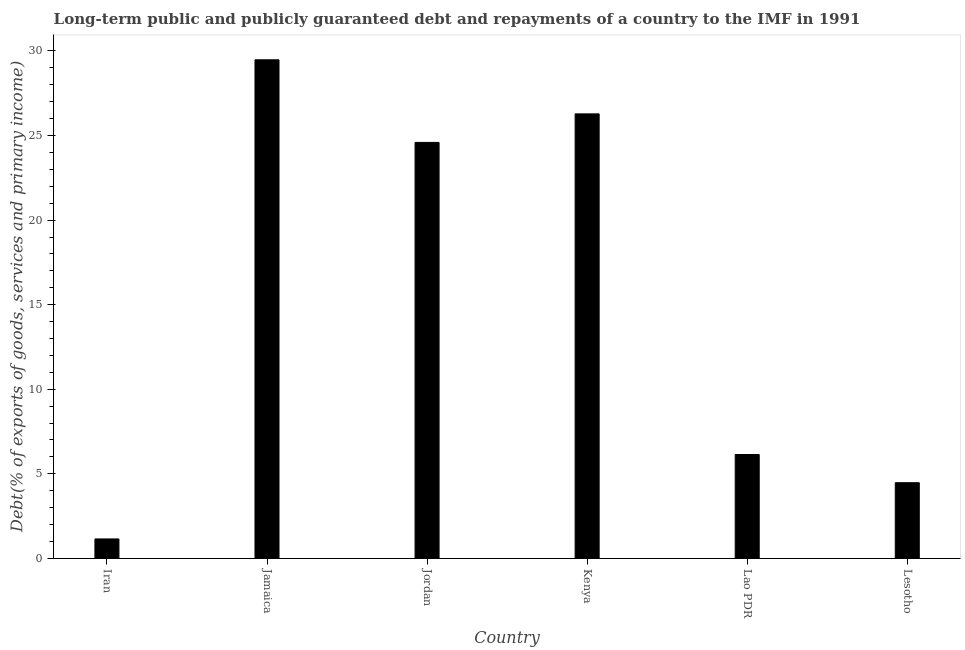Does the graph contain any zero values?
Your response must be concise. No. What is the title of the graph?
Your response must be concise. Long-term public and publicly guaranteed debt and repayments of a country to the IMF in 1991. What is the label or title of the X-axis?
Give a very brief answer. Country. What is the label or title of the Y-axis?
Your answer should be compact. Debt(% of exports of goods, services and primary income). What is the debt service in Jamaica?
Ensure brevity in your answer.  29.48. Across all countries, what is the maximum debt service?
Ensure brevity in your answer.  29.48. Across all countries, what is the minimum debt service?
Make the answer very short. 1.15. In which country was the debt service maximum?
Provide a succinct answer. Jamaica. In which country was the debt service minimum?
Provide a short and direct response. Iran. What is the sum of the debt service?
Give a very brief answer. 92.12. What is the difference between the debt service in Jordan and Kenya?
Give a very brief answer. -1.69. What is the average debt service per country?
Give a very brief answer. 15.35. What is the median debt service?
Provide a short and direct response. 15.37. What is the ratio of the debt service in Kenya to that in Lao PDR?
Make the answer very short. 4.28. Is the debt service in Jordan less than that in Kenya?
Keep it short and to the point. Yes. Is the difference between the debt service in Jamaica and Kenya greater than the difference between any two countries?
Offer a very short reply. No. What is the difference between the highest and the second highest debt service?
Your response must be concise. 3.2. Is the sum of the debt service in Iran and Jamaica greater than the maximum debt service across all countries?
Keep it short and to the point. Yes. What is the difference between the highest and the lowest debt service?
Give a very brief answer. 28.33. How many bars are there?
Your response must be concise. 6. Are all the bars in the graph horizontal?
Provide a succinct answer. No. How many countries are there in the graph?
Provide a succinct answer. 6. What is the Debt(% of exports of goods, services and primary income) of Iran?
Keep it short and to the point. 1.15. What is the Debt(% of exports of goods, services and primary income) of Jamaica?
Offer a very short reply. 29.48. What is the Debt(% of exports of goods, services and primary income) of Jordan?
Offer a terse response. 24.59. What is the Debt(% of exports of goods, services and primary income) of Kenya?
Offer a terse response. 26.28. What is the Debt(% of exports of goods, services and primary income) of Lao PDR?
Provide a succinct answer. 6.14. What is the Debt(% of exports of goods, services and primary income) of Lesotho?
Your answer should be very brief. 4.47. What is the difference between the Debt(% of exports of goods, services and primary income) in Iran and Jamaica?
Your answer should be compact. -28.33. What is the difference between the Debt(% of exports of goods, services and primary income) in Iran and Jordan?
Your response must be concise. -23.44. What is the difference between the Debt(% of exports of goods, services and primary income) in Iran and Kenya?
Your response must be concise. -25.13. What is the difference between the Debt(% of exports of goods, services and primary income) in Iran and Lao PDR?
Your answer should be very brief. -4.99. What is the difference between the Debt(% of exports of goods, services and primary income) in Iran and Lesotho?
Provide a succinct answer. -3.32. What is the difference between the Debt(% of exports of goods, services and primary income) in Jamaica and Jordan?
Make the answer very short. 4.88. What is the difference between the Debt(% of exports of goods, services and primary income) in Jamaica and Kenya?
Give a very brief answer. 3.2. What is the difference between the Debt(% of exports of goods, services and primary income) in Jamaica and Lao PDR?
Offer a terse response. 23.34. What is the difference between the Debt(% of exports of goods, services and primary income) in Jamaica and Lesotho?
Your answer should be compact. 25. What is the difference between the Debt(% of exports of goods, services and primary income) in Jordan and Kenya?
Ensure brevity in your answer.  -1.69. What is the difference between the Debt(% of exports of goods, services and primary income) in Jordan and Lao PDR?
Offer a very short reply. 18.45. What is the difference between the Debt(% of exports of goods, services and primary income) in Jordan and Lesotho?
Your response must be concise. 20.12. What is the difference between the Debt(% of exports of goods, services and primary income) in Kenya and Lao PDR?
Your answer should be compact. 20.14. What is the difference between the Debt(% of exports of goods, services and primary income) in Kenya and Lesotho?
Keep it short and to the point. 21.81. What is the difference between the Debt(% of exports of goods, services and primary income) in Lao PDR and Lesotho?
Your answer should be compact. 1.67. What is the ratio of the Debt(% of exports of goods, services and primary income) in Iran to that in Jamaica?
Ensure brevity in your answer.  0.04. What is the ratio of the Debt(% of exports of goods, services and primary income) in Iran to that in Jordan?
Give a very brief answer. 0.05. What is the ratio of the Debt(% of exports of goods, services and primary income) in Iran to that in Kenya?
Make the answer very short. 0.04. What is the ratio of the Debt(% of exports of goods, services and primary income) in Iran to that in Lao PDR?
Make the answer very short. 0.19. What is the ratio of the Debt(% of exports of goods, services and primary income) in Iran to that in Lesotho?
Provide a succinct answer. 0.26. What is the ratio of the Debt(% of exports of goods, services and primary income) in Jamaica to that in Jordan?
Provide a short and direct response. 1.2. What is the ratio of the Debt(% of exports of goods, services and primary income) in Jamaica to that in Kenya?
Give a very brief answer. 1.12. What is the ratio of the Debt(% of exports of goods, services and primary income) in Jamaica to that in Lao PDR?
Your answer should be compact. 4.8. What is the ratio of the Debt(% of exports of goods, services and primary income) in Jamaica to that in Lesotho?
Offer a terse response. 6.59. What is the ratio of the Debt(% of exports of goods, services and primary income) in Jordan to that in Kenya?
Make the answer very short. 0.94. What is the ratio of the Debt(% of exports of goods, services and primary income) in Jordan to that in Lao PDR?
Your answer should be very brief. 4. What is the ratio of the Debt(% of exports of goods, services and primary income) in Jordan to that in Lesotho?
Make the answer very short. 5.5. What is the ratio of the Debt(% of exports of goods, services and primary income) in Kenya to that in Lao PDR?
Ensure brevity in your answer.  4.28. What is the ratio of the Debt(% of exports of goods, services and primary income) in Kenya to that in Lesotho?
Your response must be concise. 5.87. What is the ratio of the Debt(% of exports of goods, services and primary income) in Lao PDR to that in Lesotho?
Give a very brief answer. 1.37. 